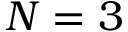<formula> <loc_0><loc_0><loc_500><loc_500>N = 3</formula> 